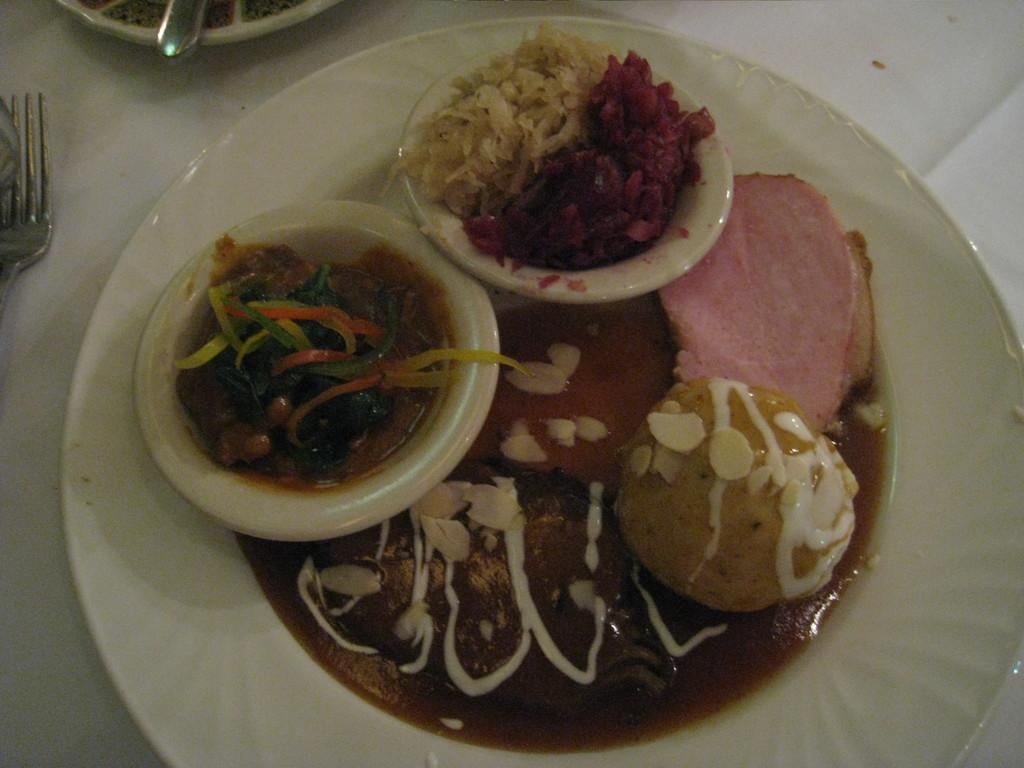What is on the table in the image? There is a plate, a fork, bowls, and food on the table in the image. What type of utensil is on the table? There is a fork on the table. How many bowls are on the table? There are bowls on the table. What is the primary purpose of the items on the table? The items on the table are used for serving and eating food. What type of vessel is present on the sofa in the image? There is no sofa or vessel present in the image; it only features a table with various items on it. 